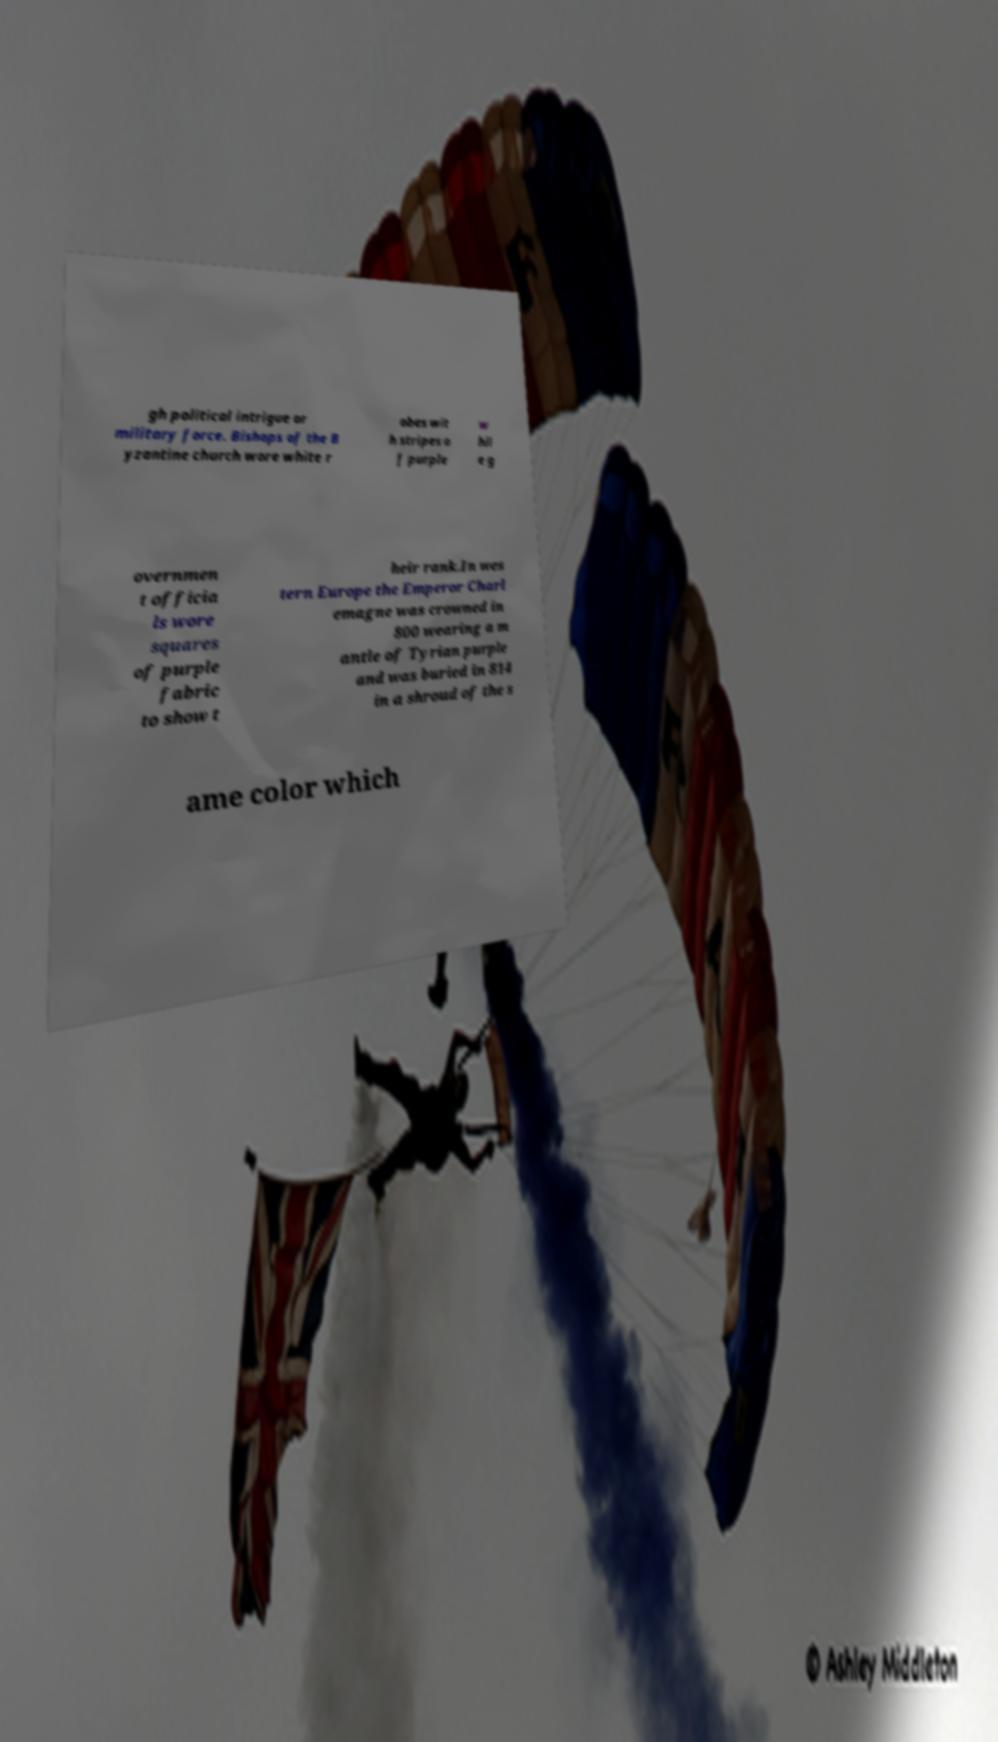Could you assist in decoding the text presented in this image and type it out clearly? gh political intrigue or military force. Bishops of the B yzantine church wore white r obes wit h stripes o f purple w hil e g overnmen t officia ls wore squares of purple fabric to show t heir rank.In wes tern Europe the Emperor Charl emagne was crowned in 800 wearing a m antle of Tyrian purple and was buried in 814 in a shroud of the s ame color which 